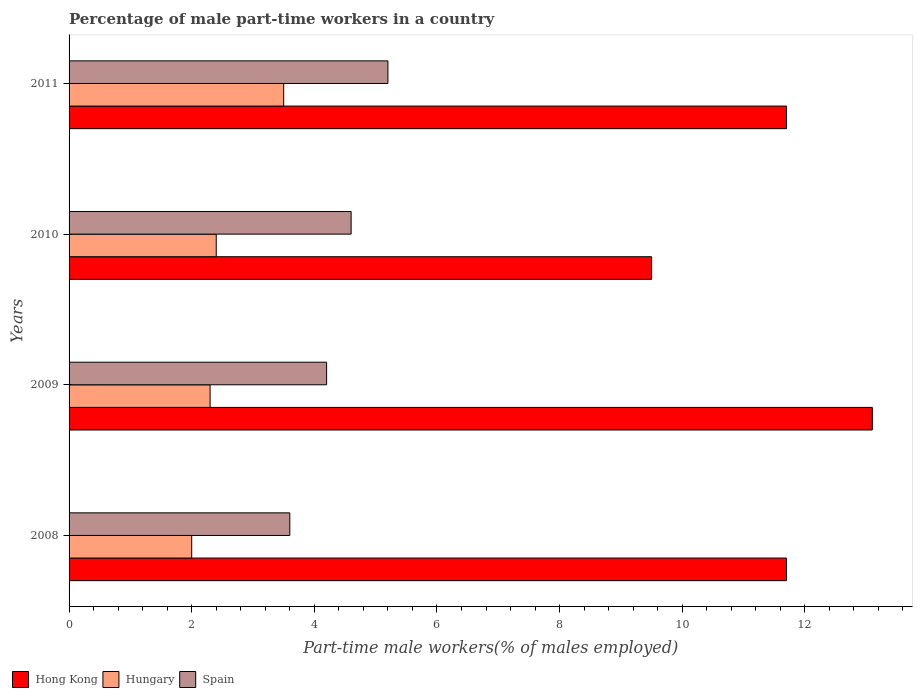Are the number of bars on each tick of the Y-axis equal?
Offer a very short reply. Yes. How many bars are there on the 1st tick from the bottom?
Keep it short and to the point. 3. What is the percentage of male part-time workers in Hong Kong in 2009?
Offer a terse response. 13.1. Across all years, what is the maximum percentage of male part-time workers in Spain?
Provide a succinct answer. 5.2. Across all years, what is the minimum percentage of male part-time workers in Hungary?
Your answer should be very brief. 2. In which year was the percentage of male part-time workers in Spain minimum?
Give a very brief answer. 2008. What is the total percentage of male part-time workers in Spain in the graph?
Keep it short and to the point. 17.6. What is the difference between the percentage of male part-time workers in Hong Kong in 2009 and that in 2011?
Your answer should be very brief. 1.4. What is the difference between the percentage of male part-time workers in Hong Kong in 2011 and the percentage of male part-time workers in Hungary in 2008?
Your response must be concise. 9.7. What is the average percentage of male part-time workers in Spain per year?
Your response must be concise. 4.4. In the year 2010, what is the difference between the percentage of male part-time workers in Hong Kong and percentage of male part-time workers in Hungary?
Ensure brevity in your answer.  7.1. What is the ratio of the percentage of male part-time workers in Hungary in 2010 to that in 2011?
Your answer should be very brief. 0.69. Is the percentage of male part-time workers in Hungary in 2008 less than that in 2010?
Give a very brief answer. Yes. What is the difference between the highest and the second highest percentage of male part-time workers in Hungary?
Your answer should be compact. 1.1. What does the 1st bar from the top in 2010 represents?
Give a very brief answer. Spain. What does the 3rd bar from the bottom in 2011 represents?
Provide a succinct answer. Spain. How many years are there in the graph?
Provide a short and direct response. 4. What is the difference between two consecutive major ticks on the X-axis?
Ensure brevity in your answer.  2. Are the values on the major ticks of X-axis written in scientific E-notation?
Ensure brevity in your answer.  No. Does the graph contain any zero values?
Make the answer very short. No. What is the title of the graph?
Ensure brevity in your answer.  Percentage of male part-time workers in a country. Does "India" appear as one of the legend labels in the graph?
Keep it short and to the point. No. What is the label or title of the X-axis?
Offer a terse response. Part-time male workers(% of males employed). What is the label or title of the Y-axis?
Provide a short and direct response. Years. What is the Part-time male workers(% of males employed) in Hong Kong in 2008?
Give a very brief answer. 11.7. What is the Part-time male workers(% of males employed) of Hungary in 2008?
Your answer should be very brief. 2. What is the Part-time male workers(% of males employed) of Spain in 2008?
Your answer should be very brief. 3.6. What is the Part-time male workers(% of males employed) of Hong Kong in 2009?
Make the answer very short. 13.1. What is the Part-time male workers(% of males employed) of Hungary in 2009?
Provide a short and direct response. 2.3. What is the Part-time male workers(% of males employed) in Spain in 2009?
Ensure brevity in your answer.  4.2. What is the Part-time male workers(% of males employed) of Hungary in 2010?
Ensure brevity in your answer.  2.4. What is the Part-time male workers(% of males employed) in Spain in 2010?
Make the answer very short. 4.6. What is the Part-time male workers(% of males employed) in Hong Kong in 2011?
Ensure brevity in your answer.  11.7. What is the Part-time male workers(% of males employed) of Spain in 2011?
Your response must be concise. 5.2. Across all years, what is the maximum Part-time male workers(% of males employed) in Hong Kong?
Your answer should be compact. 13.1. Across all years, what is the maximum Part-time male workers(% of males employed) in Spain?
Provide a succinct answer. 5.2. Across all years, what is the minimum Part-time male workers(% of males employed) of Spain?
Your response must be concise. 3.6. What is the total Part-time male workers(% of males employed) in Spain in the graph?
Give a very brief answer. 17.6. What is the difference between the Part-time male workers(% of males employed) in Hungary in 2008 and that in 2009?
Provide a short and direct response. -0.3. What is the difference between the Part-time male workers(% of males employed) of Hong Kong in 2008 and that in 2010?
Offer a terse response. 2.2. What is the difference between the Part-time male workers(% of males employed) of Hungary in 2008 and that in 2011?
Keep it short and to the point. -1.5. What is the difference between the Part-time male workers(% of males employed) of Spain in 2008 and that in 2011?
Ensure brevity in your answer.  -1.6. What is the difference between the Part-time male workers(% of males employed) of Hungary in 2009 and that in 2010?
Offer a very short reply. -0.1. What is the difference between the Part-time male workers(% of males employed) in Hong Kong in 2009 and that in 2011?
Your response must be concise. 1.4. What is the difference between the Part-time male workers(% of males employed) in Hong Kong in 2010 and that in 2011?
Your response must be concise. -2.2. What is the difference between the Part-time male workers(% of males employed) in Spain in 2010 and that in 2011?
Your answer should be very brief. -0.6. What is the difference between the Part-time male workers(% of males employed) of Hong Kong in 2008 and the Part-time male workers(% of males employed) of Spain in 2009?
Give a very brief answer. 7.5. What is the difference between the Part-time male workers(% of males employed) in Hungary in 2008 and the Part-time male workers(% of males employed) in Spain in 2009?
Make the answer very short. -2.2. What is the difference between the Part-time male workers(% of males employed) of Hong Kong in 2008 and the Part-time male workers(% of males employed) of Hungary in 2010?
Ensure brevity in your answer.  9.3. What is the difference between the Part-time male workers(% of males employed) in Hong Kong in 2008 and the Part-time male workers(% of males employed) in Spain in 2010?
Give a very brief answer. 7.1. What is the difference between the Part-time male workers(% of males employed) in Hong Kong in 2008 and the Part-time male workers(% of males employed) in Hungary in 2011?
Your answer should be very brief. 8.2. What is the difference between the Part-time male workers(% of males employed) in Hungary in 2008 and the Part-time male workers(% of males employed) in Spain in 2011?
Provide a succinct answer. -3.2. What is the difference between the Part-time male workers(% of males employed) of Hong Kong in 2009 and the Part-time male workers(% of males employed) of Hungary in 2010?
Make the answer very short. 10.7. What is the difference between the Part-time male workers(% of males employed) of Hong Kong in 2009 and the Part-time male workers(% of males employed) of Spain in 2010?
Your answer should be very brief. 8.5. What is the difference between the Part-time male workers(% of males employed) of Hungary in 2009 and the Part-time male workers(% of males employed) of Spain in 2010?
Offer a very short reply. -2.3. What is the difference between the Part-time male workers(% of males employed) in Hong Kong in 2009 and the Part-time male workers(% of males employed) in Hungary in 2011?
Provide a short and direct response. 9.6. What is the difference between the Part-time male workers(% of males employed) of Hungary in 2009 and the Part-time male workers(% of males employed) of Spain in 2011?
Keep it short and to the point. -2.9. What is the difference between the Part-time male workers(% of males employed) in Hong Kong in 2010 and the Part-time male workers(% of males employed) in Hungary in 2011?
Offer a terse response. 6. What is the average Part-time male workers(% of males employed) of Hong Kong per year?
Your answer should be compact. 11.5. What is the average Part-time male workers(% of males employed) of Hungary per year?
Provide a succinct answer. 2.55. What is the average Part-time male workers(% of males employed) in Spain per year?
Give a very brief answer. 4.4. In the year 2008, what is the difference between the Part-time male workers(% of males employed) in Hong Kong and Part-time male workers(% of males employed) in Hungary?
Ensure brevity in your answer.  9.7. In the year 2008, what is the difference between the Part-time male workers(% of males employed) of Hong Kong and Part-time male workers(% of males employed) of Spain?
Ensure brevity in your answer.  8.1. In the year 2008, what is the difference between the Part-time male workers(% of males employed) in Hungary and Part-time male workers(% of males employed) in Spain?
Your response must be concise. -1.6. In the year 2009, what is the difference between the Part-time male workers(% of males employed) in Hong Kong and Part-time male workers(% of males employed) in Hungary?
Make the answer very short. 10.8. In the year 2010, what is the difference between the Part-time male workers(% of males employed) in Hong Kong and Part-time male workers(% of males employed) in Hungary?
Your answer should be very brief. 7.1. In the year 2010, what is the difference between the Part-time male workers(% of males employed) in Hong Kong and Part-time male workers(% of males employed) in Spain?
Make the answer very short. 4.9. In the year 2011, what is the difference between the Part-time male workers(% of males employed) in Hong Kong and Part-time male workers(% of males employed) in Hungary?
Provide a succinct answer. 8.2. In the year 2011, what is the difference between the Part-time male workers(% of males employed) of Hungary and Part-time male workers(% of males employed) of Spain?
Your answer should be compact. -1.7. What is the ratio of the Part-time male workers(% of males employed) in Hong Kong in 2008 to that in 2009?
Provide a succinct answer. 0.89. What is the ratio of the Part-time male workers(% of males employed) in Hungary in 2008 to that in 2009?
Make the answer very short. 0.87. What is the ratio of the Part-time male workers(% of males employed) in Hong Kong in 2008 to that in 2010?
Ensure brevity in your answer.  1.23. What is the ratio of the Part-time male workers(% of males employed) in Spain in 2008 to that in 2010?
Your response must be concise. 0.78. What is the ratio of the Part-time male workers(% of males employed) of Hong Kong in 2008 to that in 2011?
Provide a succinct answer. 1. What is the ratio of the Part-time male workers(% of males employed) of Spain in 2008 to that in 2011?
Your answer should be compact. 0.69. What is the ratio of the Part-time male workers(% of males employed) in Hong Kong in 2009 to that in 2010?
Offer a terse response. 1.38. What is the ratio of the Part-time male workers(% of males employed) of Spain in 2009 to that in 2010?
Give a very brief answer. 0.91. What is the ratio of the Part-time male workers(% of males employed) in Hong Kong in 2009 to that in 2011?
Your answer should be very brief. 1.12. What is the ratio of the Part-time male workers(% of males employed) in Hungary in 2009 to that in 2011?
Keep it short and to the point. 0.66. What is the ratio of the Part-time male workers(% of males employed) in Spain in 2009 to that in 2011?
Provide a succinct answer. 0.81. What is the ratio of the Part-time male workers(% of males employed) in Hong Kong in 2010 to that in 2011?
Make the answer very short. 0.81. What is the ratio of the Part-time male workers(% of males employed) of Hungary in 2010 to that in 2011?
Provide a short and direct response. 0.69. What is the ratio of the Part-time male workers(% of males employed) in Spain in 2010 to that in 2011?
Make the answer very short. 0.88. What is the difference between the highest and the second highest Part-time male workers(% of males employed) of Hungary?
Your answer should be compact. 1.1. What is the difference between the highest and the lowest Part-time male workers(% of males employed) in Spain?
Keep it short and to the point. 1.6. 